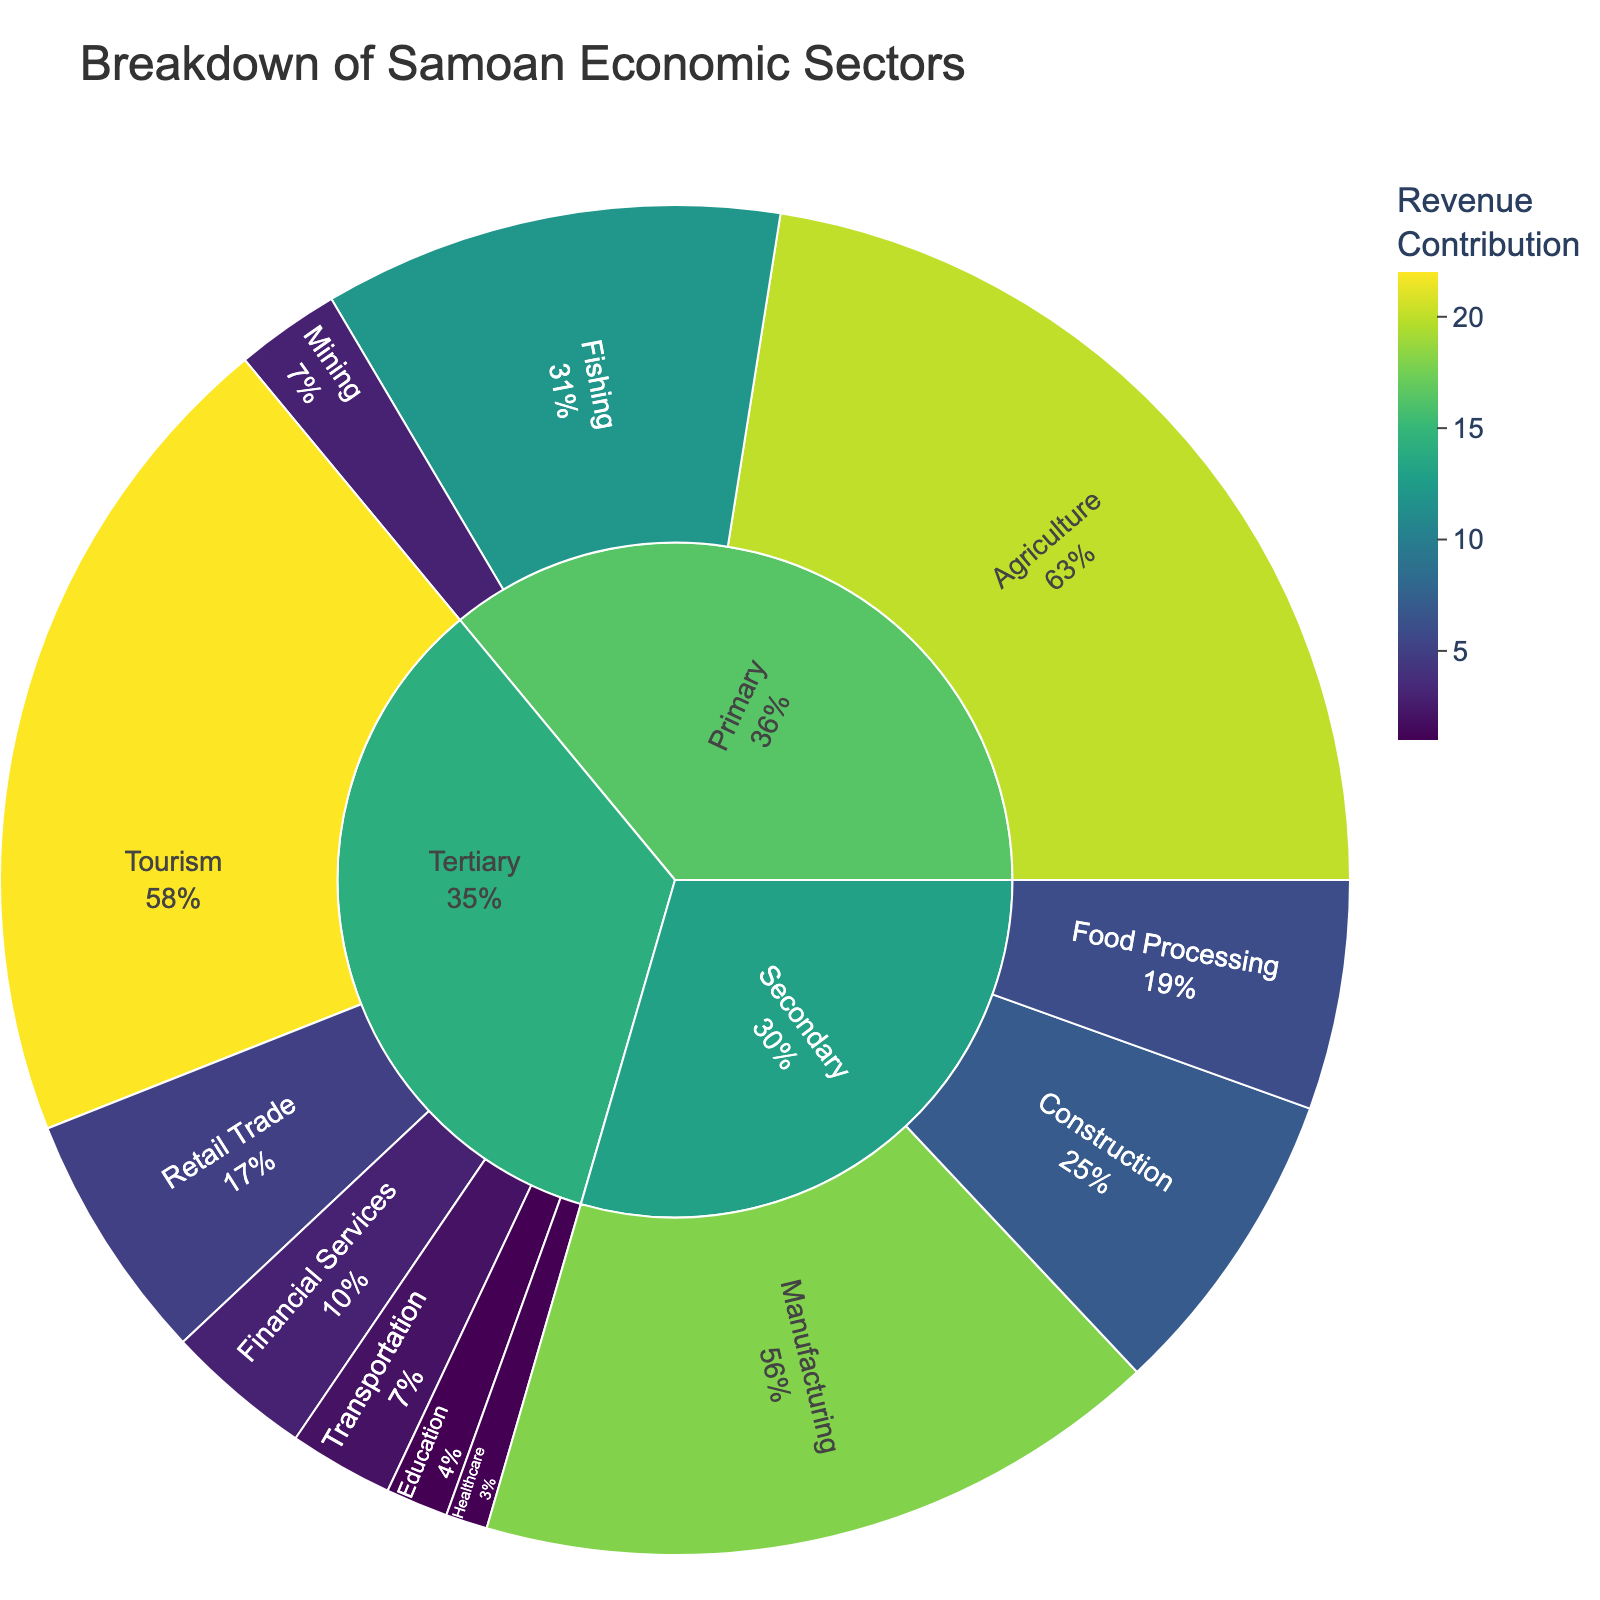What's the title of the sunburst plot? The title of the sunburst plot is usually displayed prominently at the top of the figure.
Answer: Breakdown of Samoan Economic Sectors Which sector has the highest revenue contribution in the figure? The sector with the highest revenue contribution would be indicated by the largest partition of the outer ring in the sunburst plot.
Answer: Tertiary How many industries are in the Primary sector? By looking at the Primary sector slice in the sunburst plot, you can count the number of industries branching from it.
Answer: 3 Which industry in the Secondary sector has the lowest employment? The Secondary sector will have multiple industries, each with an employment value. The industry with the smallest segment representing employment is the one with the lowest employment.
Answer: Food Processing What's the total employment in the Tertiary sector? Sum up the employment numbers listed for each industry in the Tertiary sector.
Answer: 35 Which industry contributes the highest to revenue in the Tertiary sector? The segment with the largest share of the Tertiary sector's revenue is the one with the highest revenue contribution.
Answer: Tourism Compare the revenue contribution of Agriculture and Tourism. Which one is higher? Look at the revenue contribution for both Agriculture and Tourism as shown in their respective segments. Compare the values.
Answer: Tourism Which industries have both employment and revenue contribution equal? Check each industry's employment and revenue contribution, and identify industries where these two values are the same.
Answer: Healthcare, Education What percentage of total employment does the Fishing industry represent? Sum the total employment for all industries. Then calculate the percentage that Fishing's employment contributes to this total. (10 / (25 + 10 + 2 + 15 + 8 + 5 + 18 + 7 + 4 + 3 + 2 + 1)) * 100
Answer: 10.99% What is the difference in revenue contribution between Manufacturing and Construction? Find the revenue contributions for Manufacturing and Construction, then subtract the smaller value from the larger value. 18 - 7 = 11
Answer: 11 